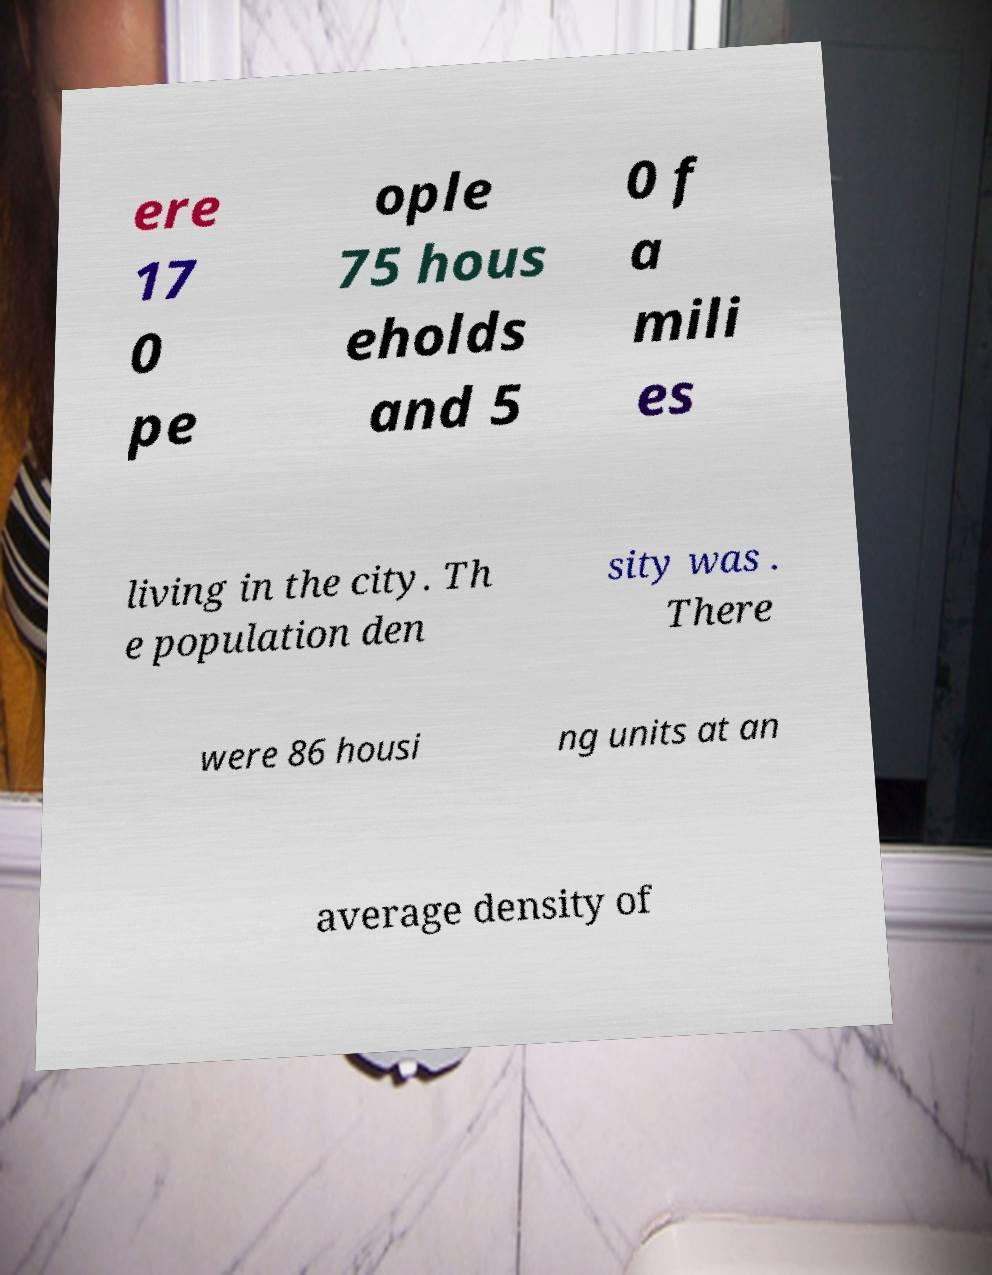Could you extract and type out the text from this image? ere 17 0 pe ople 75 hous eholds and 5 0 f a mili es living in the city. Th e population den sity was . There were 86 housi ng units at an average density of 